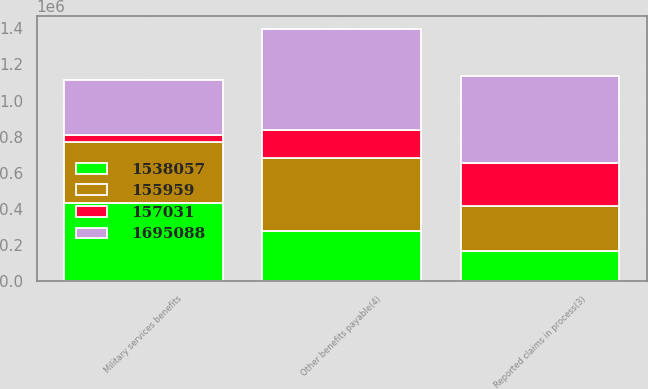Convert chart to OTSL. <chart><loc_0><loc_0><loc_500><loc_500><stacked_bar_chart><ecel><fcel>Military services benefits<fcel>Reported claims in process(3)<fcel>Other benefits payable(4)<nl><fcel>1.69509e+06<fcel>306797<fcel>486514<fcel>561221<nl><fcel>155959<fcel>341372<fcel>253054<fcel>407319<nl><fcel>1.53806e+06<fcel>430674<fcel>165254<fcel>276422<nl><fcel>157031<fcel>34575<fcel>233460<fcel>153902<nl></chart> 